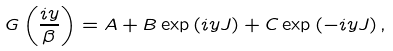Convert formula to latex. <formula><loc_0><loc_0><loc_500><loc_500>G \left ( \frac { i y } { \beta } \right ) = A + B \exp \left ( i y J \right ) + C \exp \left ( - i y J \right ) ,</formula> 